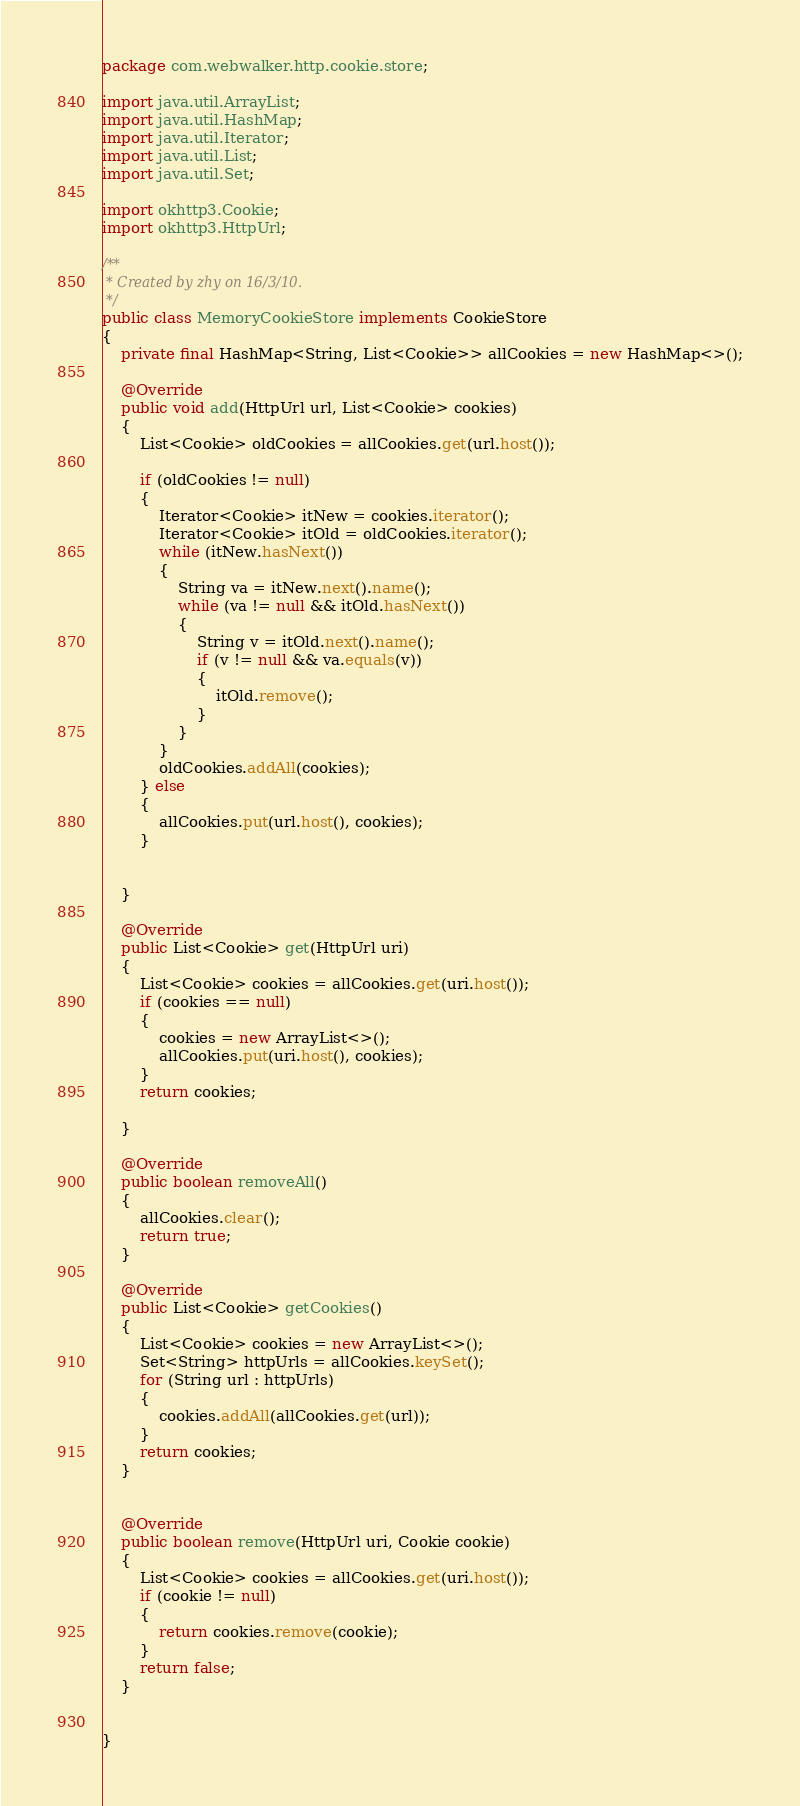Convert code to text. <code><loc_0><loc_0><loc_500><loc_500><_Java_>package com.webwalker.http.cookie.store;

import java.util.ArrayList;
import java.util.HashMap;
import java.util.Iterator;
import java.util.List;
import java.util.Set;

import okhttp3.Cookie;
import okhttp3.HttpUrl;

/**
 * Created by zhy on 16/3/10.
 */
public class MemoryCookieStore implements CookieStore
{
    private final HashMap<String, List<Cookie>> allCookies = new HashMap<>();

    @Override
    public void add(HttpUrl url, List<Cookie> cookies)
    {
        List<Cookie> oldCookies = allCookies.get(url.host());

        if (oldCookies != null)
        {
            Iterator<Cookie> itNew = cookies.iterator();
            Iterator<Cookie> itOld = oldCookies.iterator();
            while (itNew.hasNext())
            {
                String va = itNew.next().name();
                while (va != null && itOld.hasNext())
                {
                    String v = itOld.next().name();
                    if (v != null && va.equals(v))
                    {
                        itOld.remove();
                    }
                }
            }
            oldCookies.addAll(cookies);
        } else
        {
            allCookies.put(url.host(), cookies);
        }


    }

    @Override
    public List<Cookie> get(HttpUrl uri)
    {
        List<Cookie> cookies = allCookies.get(uri.host());
        if (cookies == null)
        {
            cookies = new ArrayList<>();
            allCookies.put(uri.host(), cookies);
        }
        return cookies;

    }

    @Override
    public boolean removeAll()
    {
        allCookies.clear();
        return true;
    }

    @Override
    public List<Cookie> getCookies()
    {
        List<Cookie> cookies = new ArrayList<>();
        Set<String> httpUrls = allCookies.keySet();
        for (String url : httpUrls)
        {
            cookies.addAll(allCookies.get(url));
        }
        return cookies;
    }


    @Override
    public boolean remove(HttpUrl uri, Cookie cookie)
    {
        List<Cookie> cookies = allCookies.get(uri.host());
        if (cookie != null)
        {
            return cookies.remove(cookie);
        }
        return false;
    }


}
</code> 